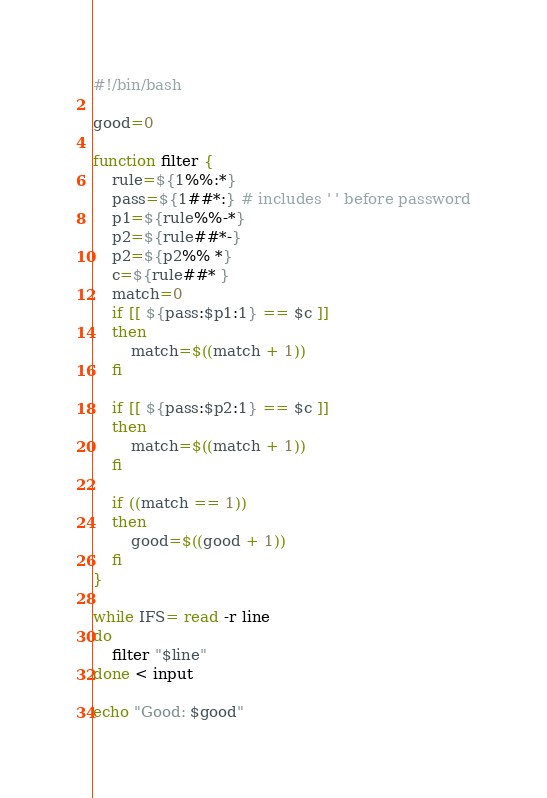<code> <loc_0><loc_0><loc_500><loc_500><_Bash_>#!/bin/bash

good=0

function filter {
	rule=${1%%:*}
	pass=${1##*:} # includes ' ' before password
	p1=${rule%%-*}
	p2=${rule##*-}
	p2=${p2%% *}
	c=${rule##* }
	match=0
	if [[ ${pass:$p1:1} == $c ]]
	then
		match=$((match + 1))
	fi

	if [[ ${pass:$p2:1} == $c ]]
	then
		match=$((match + 1))
	fi

	if ((match == 1))
	then
		good=$((good + 1))
	fi
}

while IFS= read -r line
do
	filter "$line"
done < input

echo "Good: $good"
</code> 